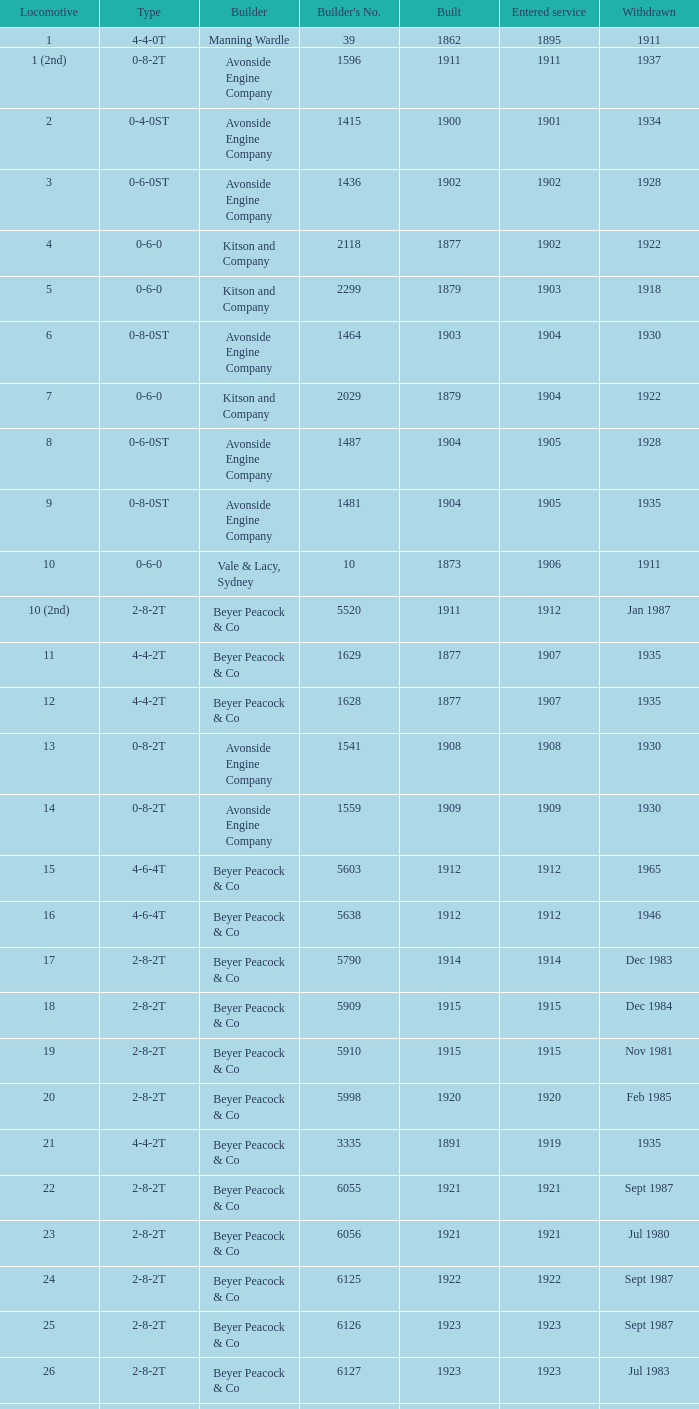Regarding locomotives with a 2-8-2t layout, which one was manufactured after 1911 and initiated service before the year 1915? 17.0. 